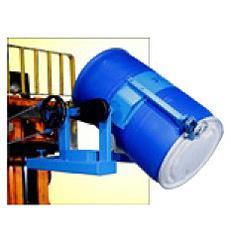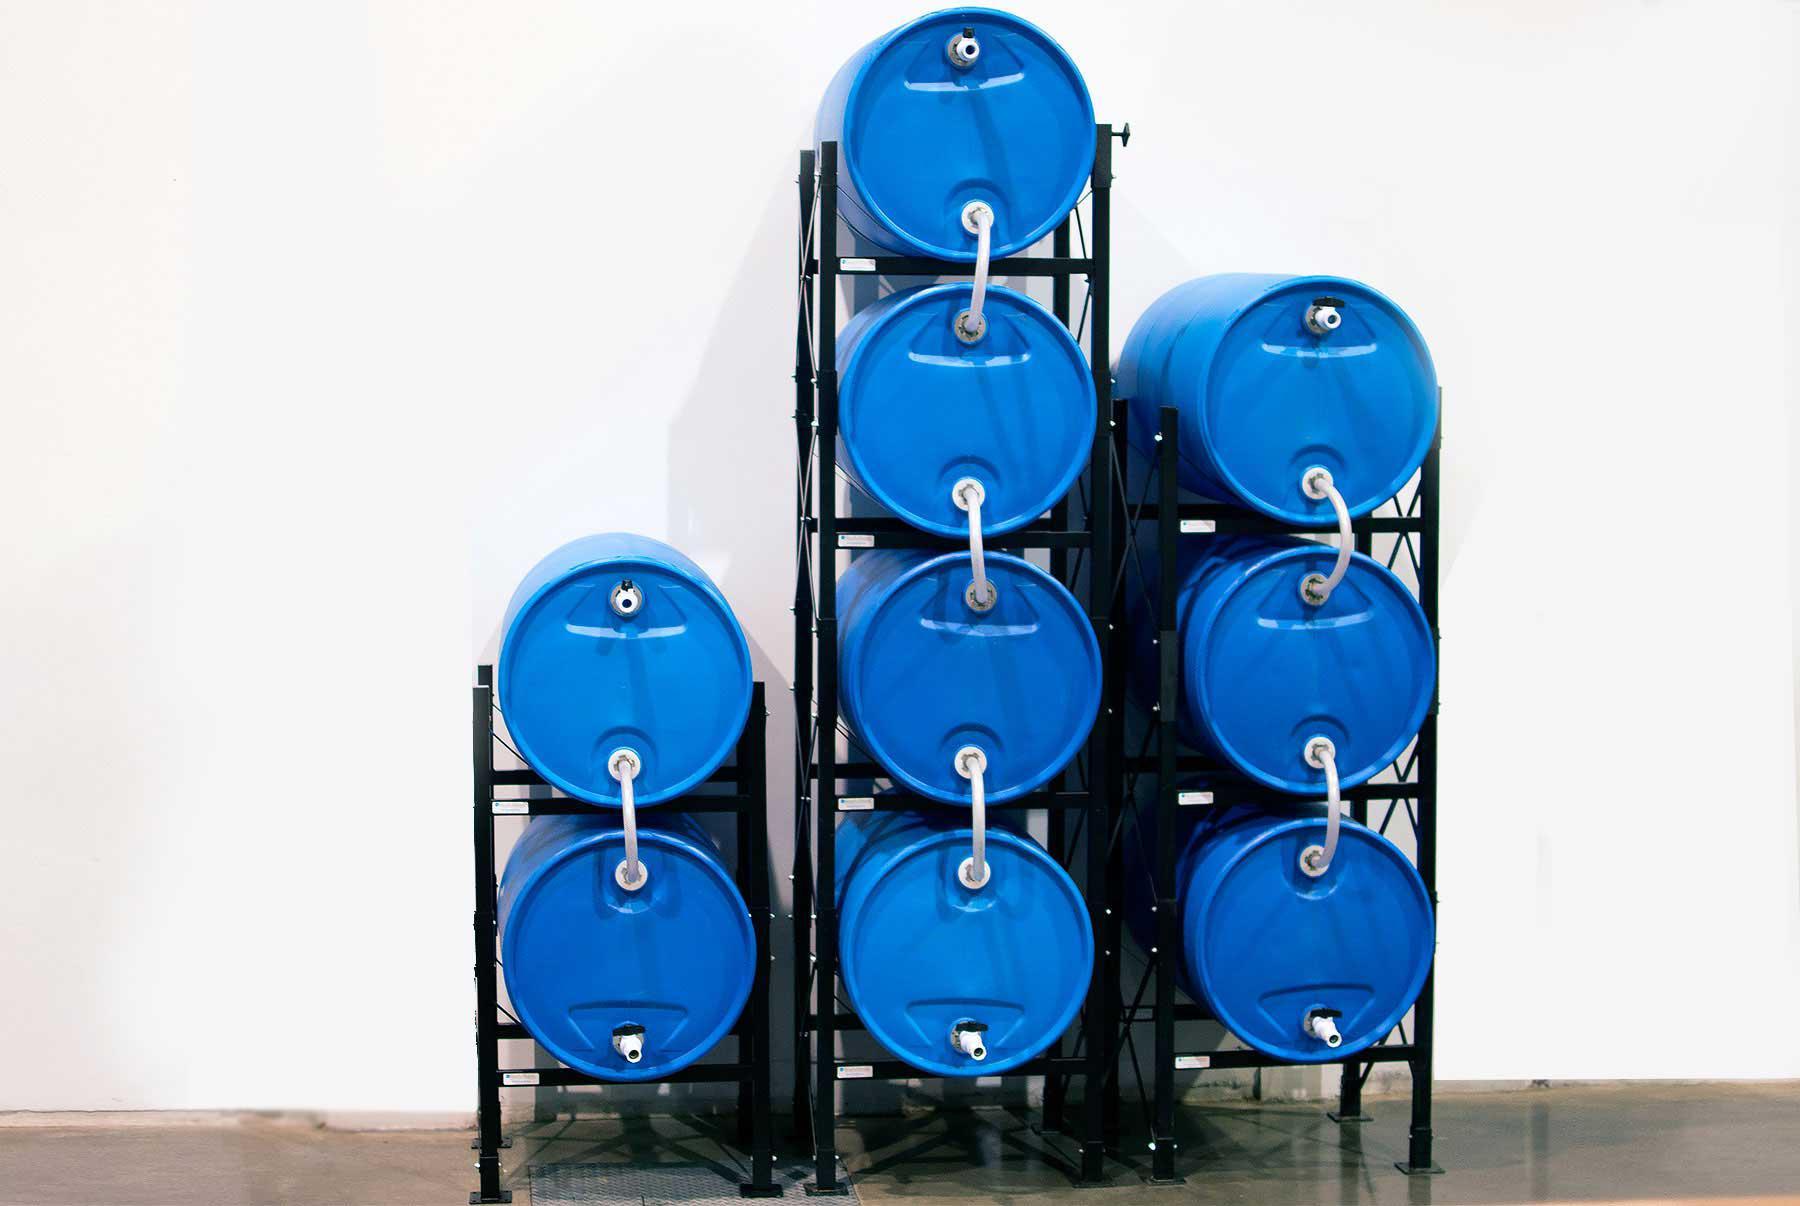The first image is the image on the left, the second image is the image on the right. For the images displayed, is the sentence "One image shows exactly two blue barrels." factually correct? Answer yes or no. No. The first image is the image on the left, the second image is the image on the right. Considering the images on both sides, is "Each image contains at least one blue barrel, and at least 6 blue barrels in total are shown." valid? Answer yes or no. Yes. 